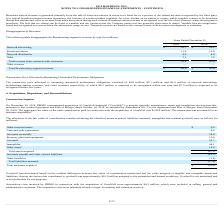According to Hc2 Holdings's financial document, Where is the network advertising revenue generated from? Based on the financial document, the answer is primarily from the sale of television airtime for programs or advertisements. Also, What does the network distribution revenue consist of? Based on the financial document, the answer is payments received from cable, satellite and other multiple video program distribution systems for their retransmission of our network content.. Also, Where is the broadcast revenue generated from? primarily from the sale of television airtime in return for a fixed fee or a portion of the related ad sales recognized by the third party.. The document states: "Broadcast station revenue is generated primarily from the sale of television airtime in return for a fixed fee or a portion of the related ad sales re..." Also, can you calculate: What is the change in the network advertising revenue from 2018 to 2019? Based on the calculation: 22.7 - 28.2, the result is -5.5 (in millions). This is based on the information: "Network advertising $ 22.7 $ 28.2 Network advertising $ 22.7 $ 28.2..." The key data points involved are: 22.7, 28.2. Also, can you calculate: What is the average broadcast station revenue for 2018 and 2019? To answer this question, I need to perform calculations using the financial data. The calculation is: (11.9 + 10.8) / 2, which equals 11.35 (in millions). This is based on the information: "Broadcast station 11.9 10.8 Broadcast station 11.9 10.8..." The key data points involved are: 10.8, 11.9. Also, can you calculate: What is the percentage change in the network distribution revenue from 2018 to 2019? To answer this question, I need to perform calculations using the financial data. The calculation is: 4.9 / 4.8 - 1, which equals 2.08 (percentage). This is based on the information: "Network distribution 4.9 4.8 Network distribution 4.9 4.8..." The key data points involved are: 4.8, 4.9. 